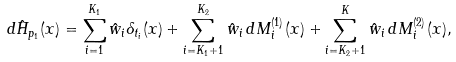<formula> <loc_0><loc_0><loc_500><loc_500>d \hat { H } _ { p _ { 1 } } ( x ) = \sum ^ { K _ { 1 } } _ { i = 1 } \hat { w } _ { i } \delta _ { t _ { i } } ( x ) + \sum ^ { K _ { 2 } } _ { i = K _ { 1 } + 1 } \hat { w } _ { i } \, d M ^ { ( 1 ) } _ { i } ( x ) + \sum ^ { K } _ { i = K _ { 2 } + 1 } \hat { w } _ { i } \, d M ^ { ( 2 ) } _ { i } ( x ) ,</formula> 